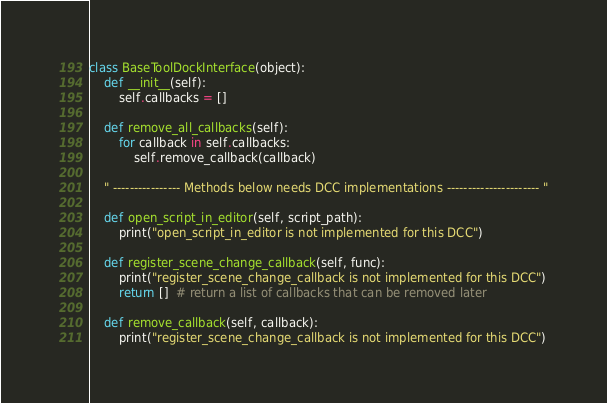<code> <loc_0><loc_0><loc_500><loc_500><_Python_>class BaseToolDockInterface(object):
    def __init__(self):
        self.callbacks = []

    def remove_all_callbacks(self):
        for callback in self.callbacks:
            self.remove_callback(callback)

    " ---------------- Methods below needs DCC implementations ---------------------- "

    def open_script_in_editor(self, script_path):
        print("open_script_in_editor is not implemented for this DCC")

    def register_scene_change_callback(self, func):
        print("register_scene_change_callback is not implemented for this DCC")
        return []  # return a list of callbacks that can be removed later

    def remove_callback(self, callback):
        print("register_scene_change_callback is not implemented for this DCC")
</code> 